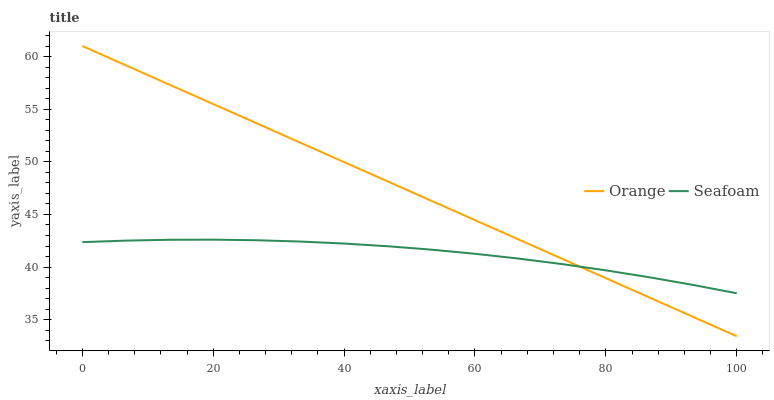Does Seafoam have the minimum area under the curve?
Answer yes or no. Yes. Does Orange have the maximum area under the curve?
Answer yes or no. Yes. Does Seafoam have the maximum area under the curve?
Answer yes or no. No. Is Orange the smoothest?
Answer yes or no. Yes. Is Seafoam the roughest?
Answer yes or no. Yes. Is Seafoam the smoothest?
Answer yes or no. No. Does Orange have the lowest value?
Answer yes or no. Yes. Does Seafoam have the lowest value?
Answer yes or no. No. Does Orange have the highest value?
Answer yes or no. Yes. Does Seafoam have the highest value?
Answer yes or no. No. Does Orange intersect Seafoam?
Answer yes or no. Yes. Is Orange less than Seafoam?
Answer yes or no. No. Is Orange greater than Seafoam?
Answer yes or no. No. 